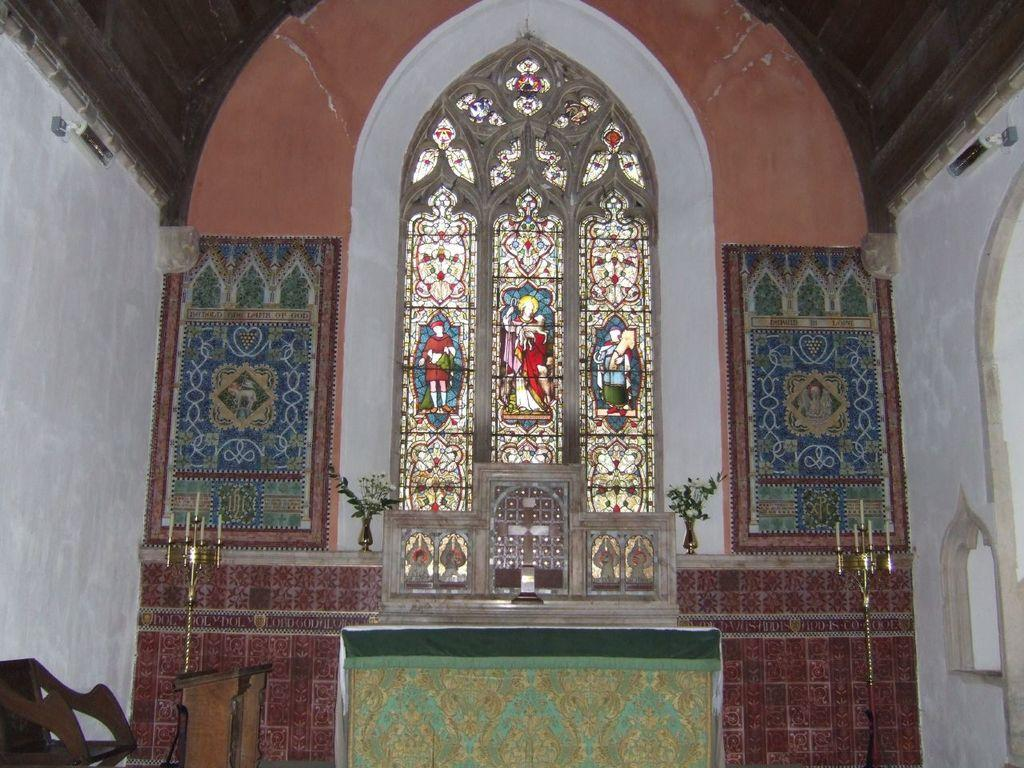What type of seating is visible in the image? There is a bench and a chair in the image. What can be found on the bench or chair? Candles are present on the bench or chair. What is the background of the image? There is a wall in the image. What is placed on the wall? There is a plant pot on the wall. What is the source of natural light in the image? There is a window in the image. What is on the window? Pictures of people are present on the window. Can you tell me how many rabbits are hopping around in the image? There are no rabbits present in the image. Who is the expert in the image? There is no expert present in the image. 